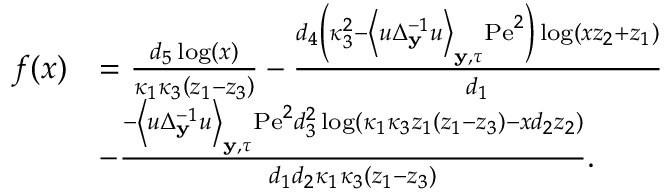<formula> <loc_0><loc_0><loc_500><loc_500>\begin{array} { r l } { f ( x ) } & { = \frac { d _ { 5 } \log ( x ) } { \kappa _ { 1 } \kappa _ { 3 } \left ( z _ { 1 } - z _ { 3 } \right ) } - \frac { d _ { 4 } \left ( \kappa _ { 3 } ^ { 2 } - \left \langle u \Delta _ { y } ^ { - 1 } u \right \rangle _ { y , \tau } P e ^ { 2 } \right ) \log \left ( x z _ { 2 } + z _ { 1 } \right ) } { d _ { 1 } } } \\ & { - \frac { - \left \langle u \Delta _ { y } ^ { - 1 } u \right \rangle _ { y , \tau } P e ^ { 2 } d _ { 3 } ^ { 2 } \log \left ( \kappa _ { 1 } \kappa _ { 3 } z _ { 1 } \left ( z _ { 1 } - z _ { 3 } \right ) - x d _ { 2 } z _ { 2 } \right ) } { d _ { 1 } d _ { 2 } \kappa _ { 1 } \kappa _ { 3 } \left ( z _ { 1 } - z _ { 3 } \right ) } . } \end{array}</formula> 